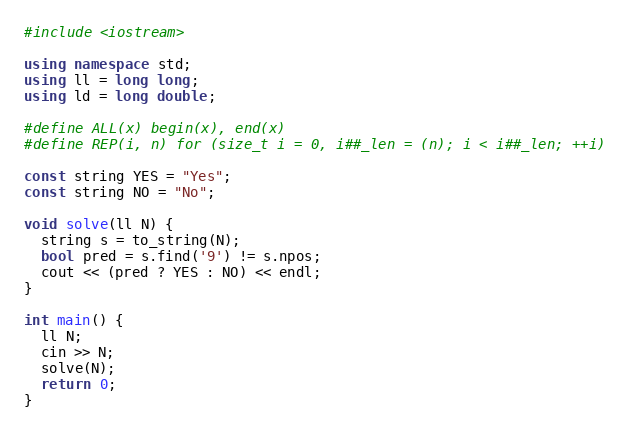<code> <loc_0><loc_0><loc_500><loc_500><_C++_>#include <iostream>

using namespace std;
using ll = long long;
using ld = long double;

#define ALL(x) begin(x), end(x)
#define REP(i, n) for (size_t i = 0, i##_len = (n); i < i##_len; ++i)

const string YES = "Yes";
const string NO = "No";

void solve(ll N) {
  string s = to_string(N);
  bool pred = s.find('9') != s.npos;
  cout << (pred ? YES : NO) << endl;
}

int main() {
  ll N;
  cin >> N;
  solve(N);
  return 0;
}
</code> 